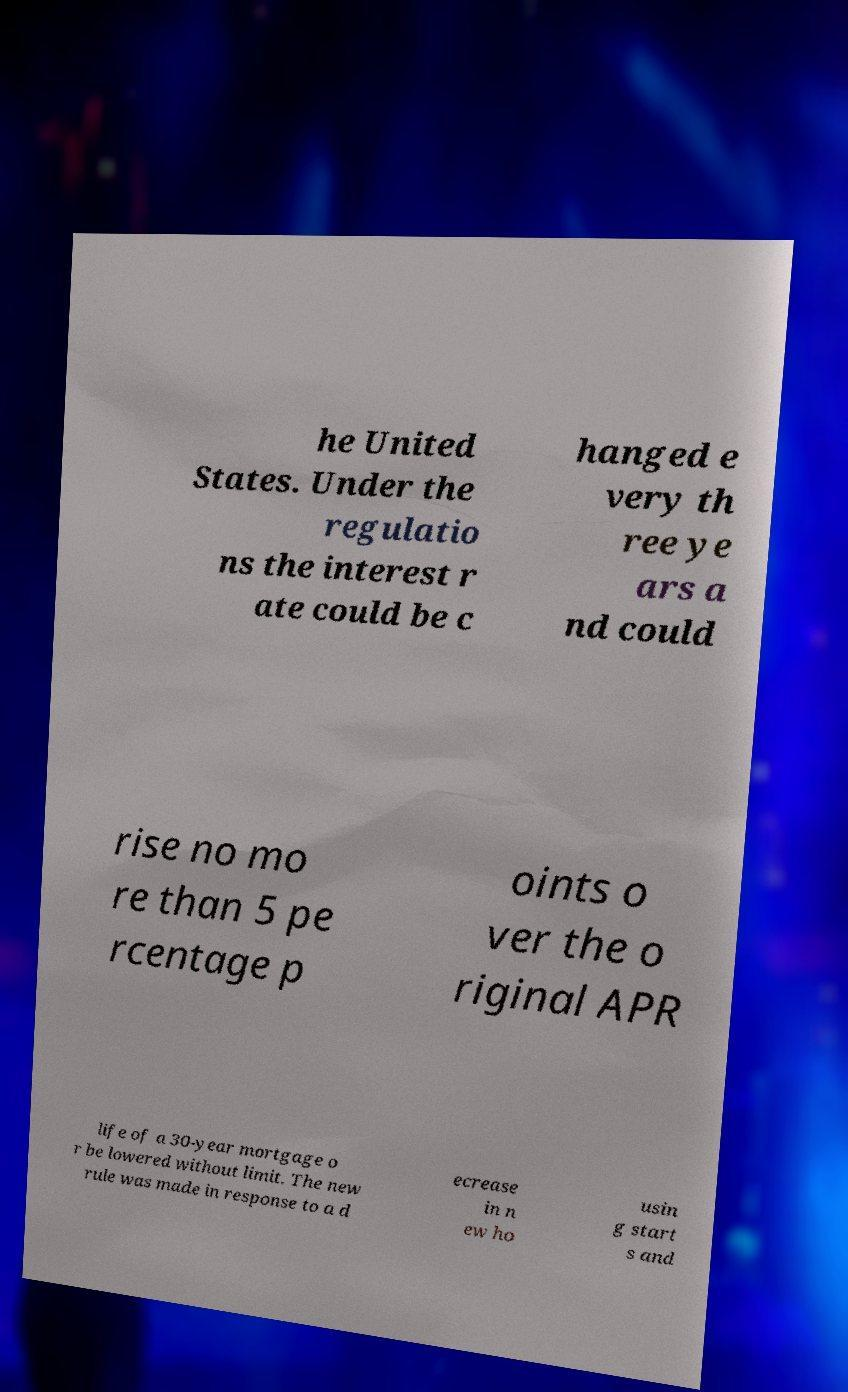Can you accurately transcribe the text from the provided image for me? he United States. Under the regulatio ns the interest r ate could be c hanged e very th ree ye ars a nd could rise no mo re than 5 pe rcentage p oints o ver the o riginal APR life of a 30-year mortgage o r be lowered without limit. The new rule was made in response to a d ecrease in n ew ho usin g start s and 